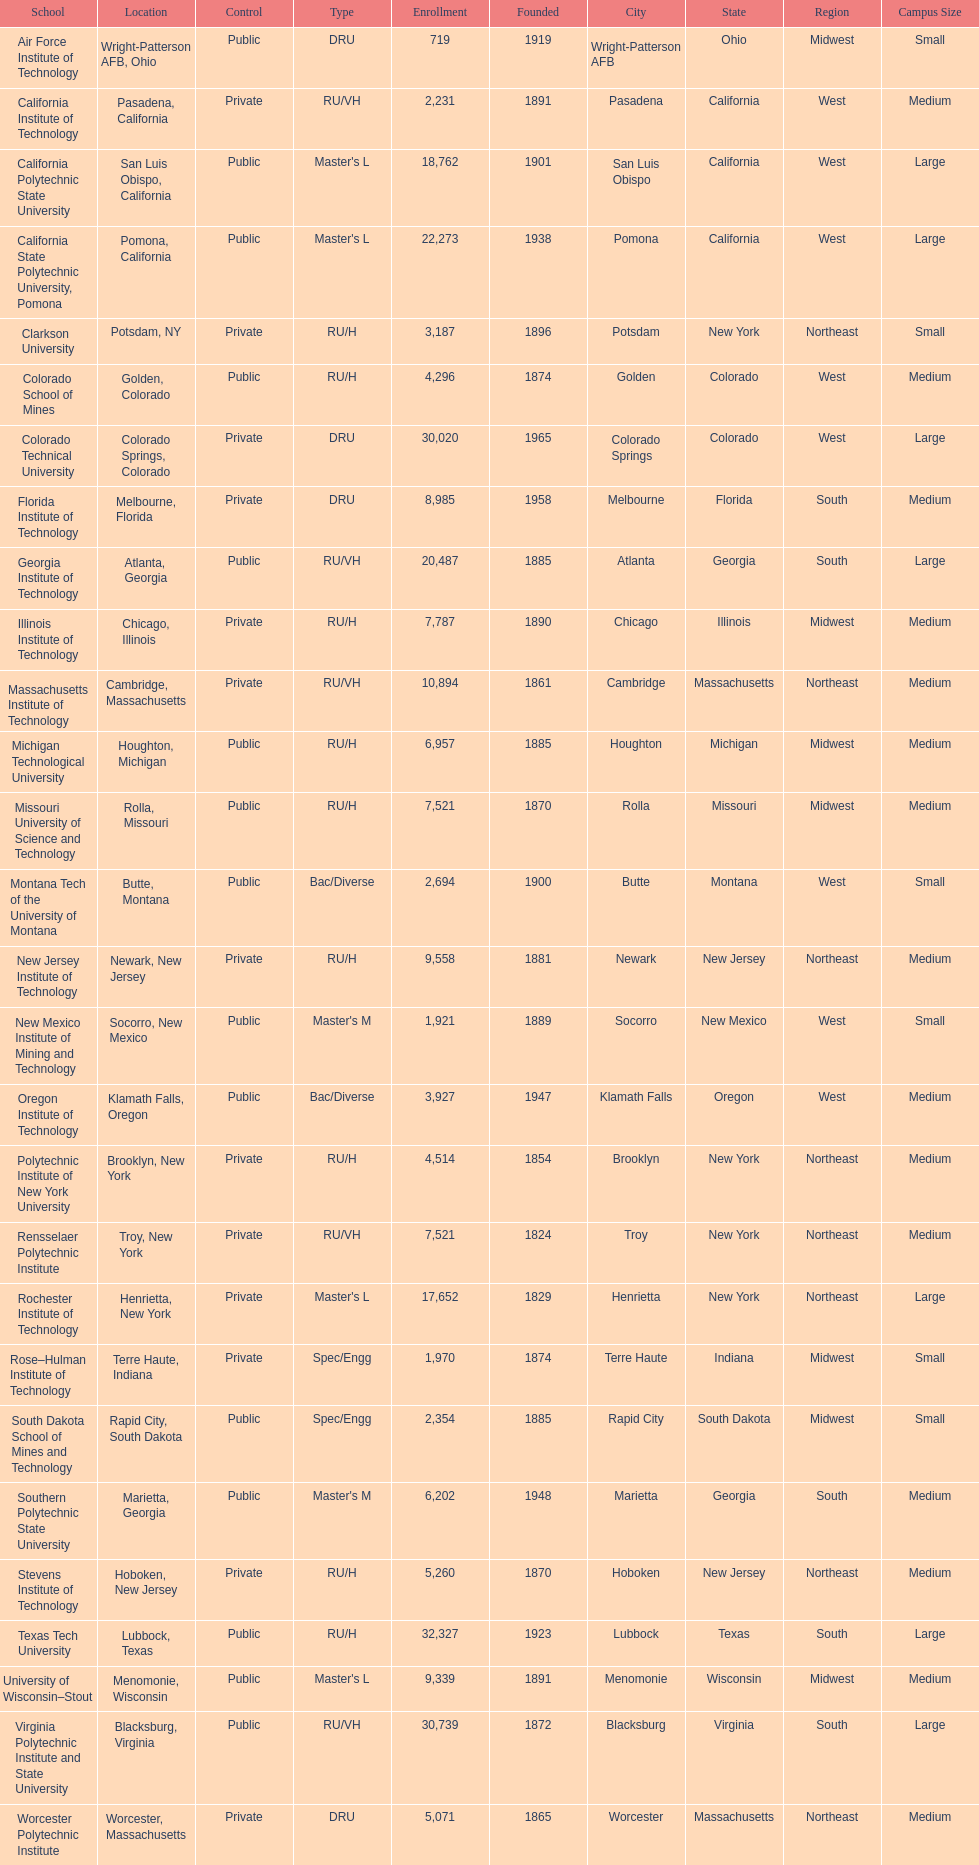What is the total number of schools listed in the table? 28. 